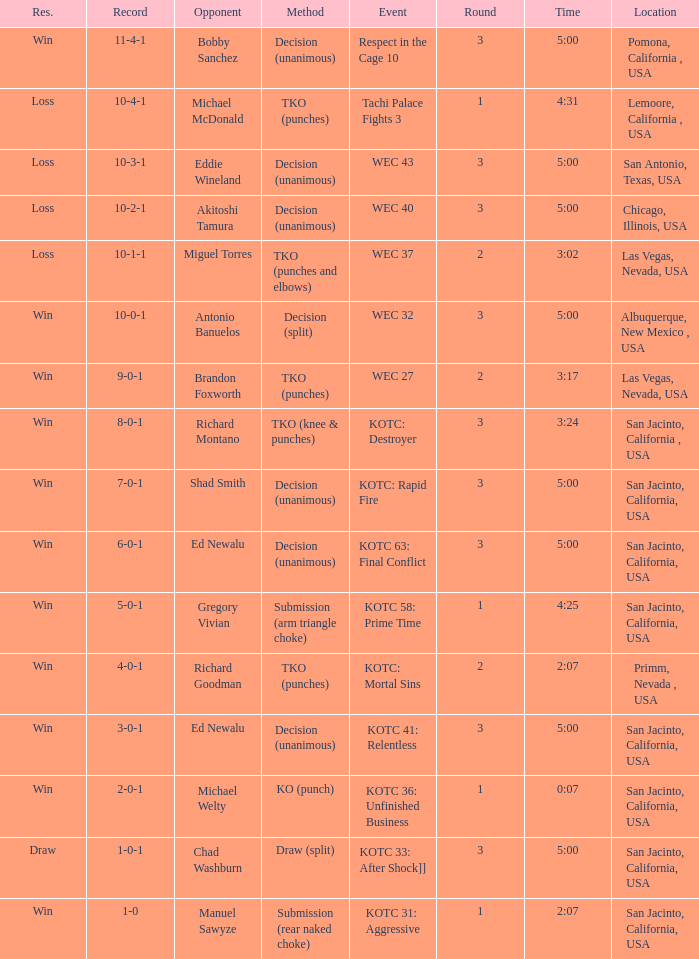When did the tachi palace fights 3 event transpire? 4:31. 